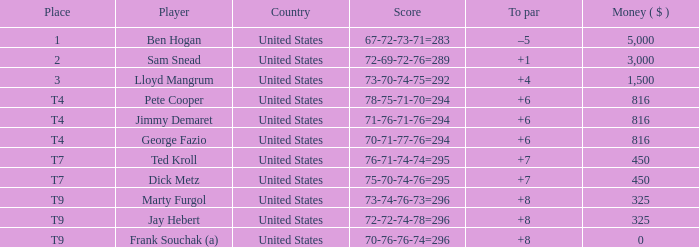Which country is Pete Cooper, who made $816, from? United States. 